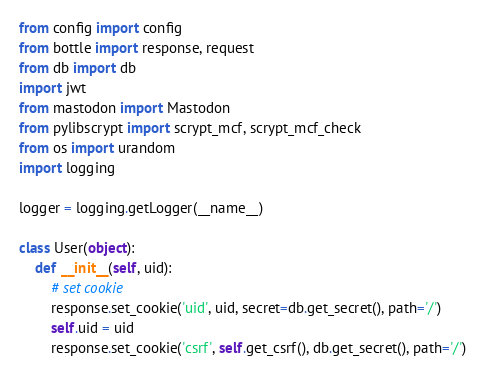<code> <loc_0><loc_0><loc_500><loc_500><_Python_>from config import config
from bottle import response, request
from db import db
import jwt
from mastodon import Mastodon
from pylibscrypt import scrypt_mcf, scrypt_mcf_check
from os import urandom
import logging

logger = logging.getLogger(__name__)

class User(object):
    def __init__(self, uid):
        # set cookie
        response.set_cookie('uid', uid, secret=db.get_secret(), path='/')
        self.uid = uid
        response.set_cookie('csrf', self.get_csrf(), db.get_secret(), path='/')
</code> 